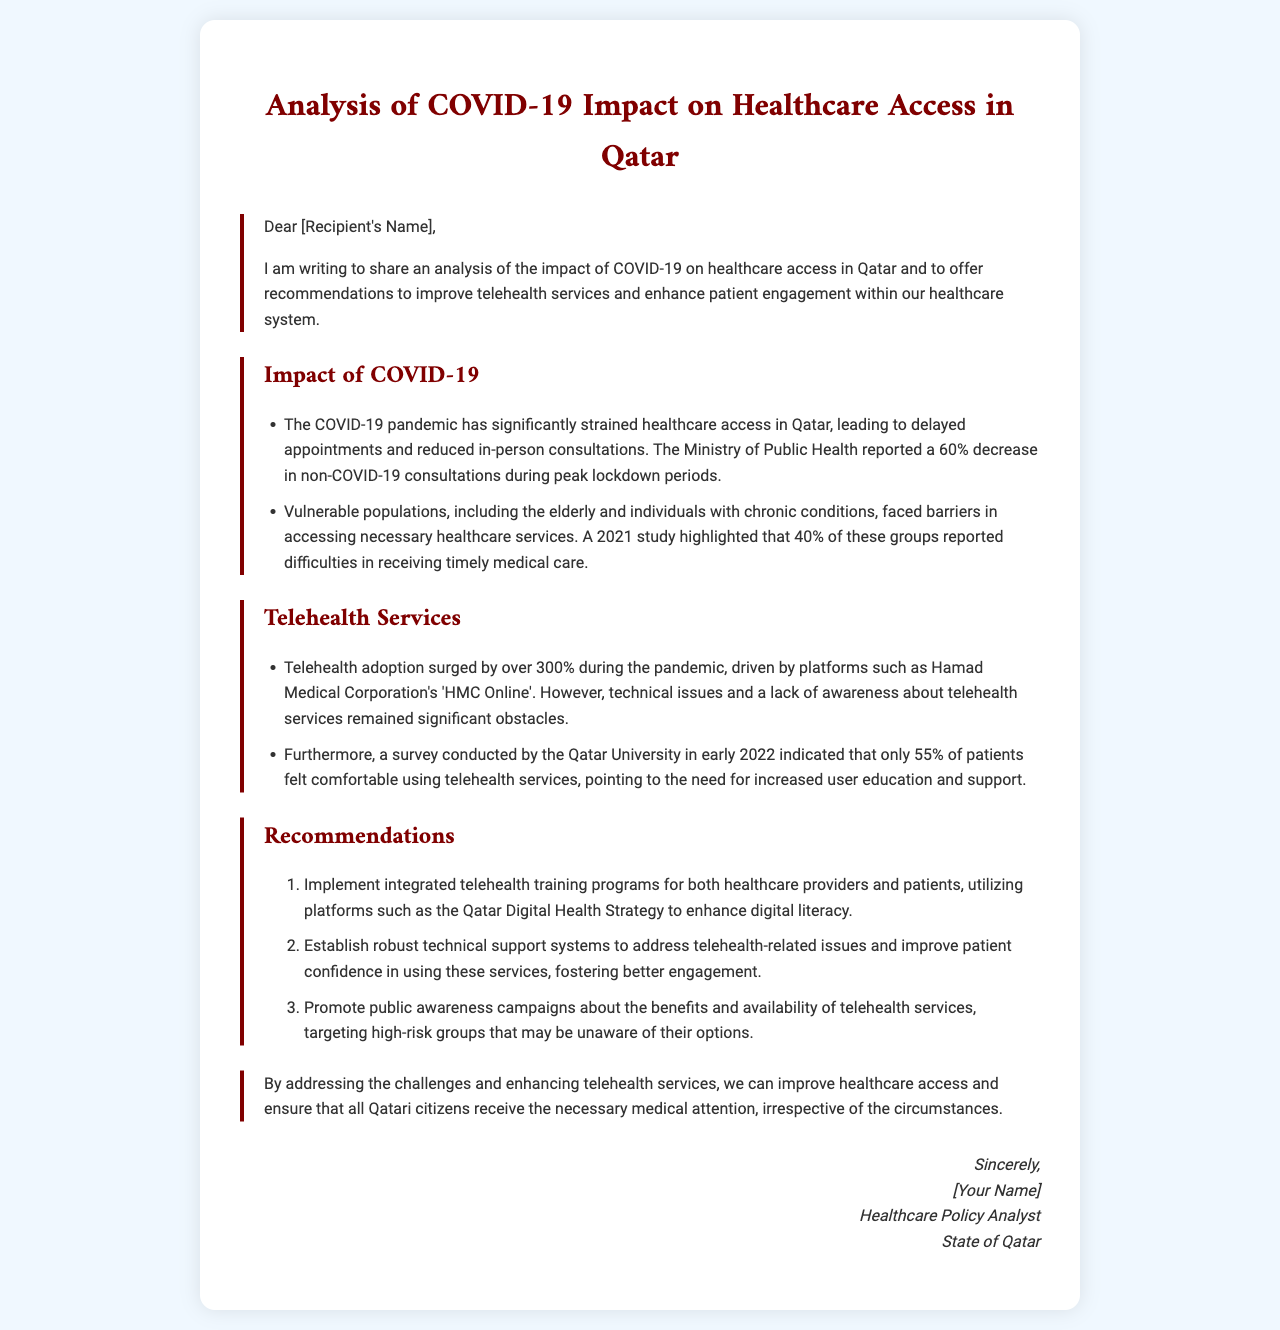What was the percentage decrease in non-COVID-19 consultations? The document states that there was a 60% decrease in non-COVID-19 consultations during peak lockdown periods.
Answer: 60% What percentage of vulnerable populations reported difficulties in accessing necessary healthcare? A 2021 study highlighted that 40% of vulnerable populations reported difficulties in receiving timely medical care.
Answer: 40% By how much did telehealth adoption surge during the pandemic? The document mentions that telehealth adoption surged by over 300% during the pandemic.
Answer: 300% What percentage of patients felt comfortable using telehealth services? A survey conducted indicated that only 55% of patients felt comfortable using telehealth services.
Answer: 55% What is one of the recommendations for enhancing patient engagement? The letter recommends implementing integrated telehealth training programs for both healthcare providers and patients to enhance digital literacy.
Answer: Implement integrated telehealth training programs Why was there a need for public awareness campaigns? The document states that public awareness campaigns are needed to inform high-risk groups that may be unaware of their options regarding telehealth services.
Answer: To inform high-risk groups What is the primary focus of this analysis letter? The letter focuses on analyzing the impact of COVID-19 on healthcare access in Qatar and offers recommendations to improve telehealth services.
Answer: Impact of COVID-19 on healthcare access What is the purpose of the closing paragraph? The closing paragraph emphasizes the importance of addressing challenges and enhancing telehealth services to improve healthcare access for all Qatari citizens.
Answer: To emphasize healthcare access improvement 